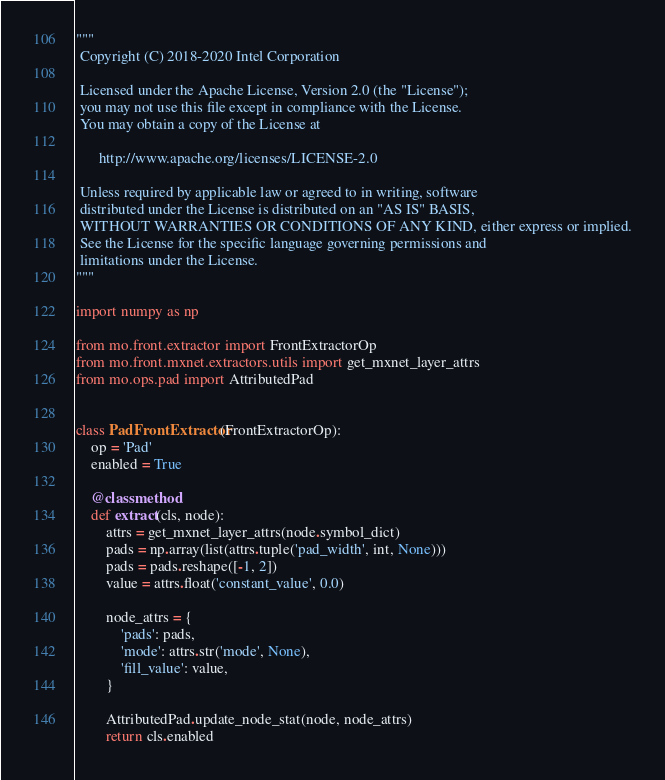Convert code to text. <code><loc_0><loc_0><loc_500><loc_500><_Python_>"""
 Copyright (C) 2018-2020 Intel Corporation

 Licensed under the Apache License, Version 2.0 (the "License");
 you may not use this file except in compliance with the License.
 You may obtain a copy of the License at

      http://www.apache.org/licenses/LICENSE-2.0

 Unless required by applicable law or agreed to in writing, software
 distributed under the License is distributed on an "AS IS" BASIS,
 WITHOUT WARRANTIES OR CONDITIONS OF ANY KIND, either express or implied.
 See the License for the specific language governing permissions and
 limitations under the License.
"""

import numpy as np

from mo.front.extractor import FrontExtractorOp
from mo.front.mxnet.extractors.utils import get_mxnet_layer_attrs
from mo.ops.pad import AttributedPad


class PadFrontExtractor(FrontExtractorOp):
    op = 'Pad'
    enabled = True

    @classmethod
    def extract(cls, node):
        attrs = get_mxnet_layer_attrs(node.symbol_dict)
        pads = np.array(list(attrs.tuple('pad_width', int, None)))
        pads = pads.reshape([-1, 2])
        value = attrs.float('constant_value', 0.0)

        node_attrs = {
            'pads': pads,
            'mode': attrs.str('mode', None),
            'fill_value': value,
        }

        AttributedPad.update_node_stat(node, node_attrs)
        return cls.enabled
</code> 